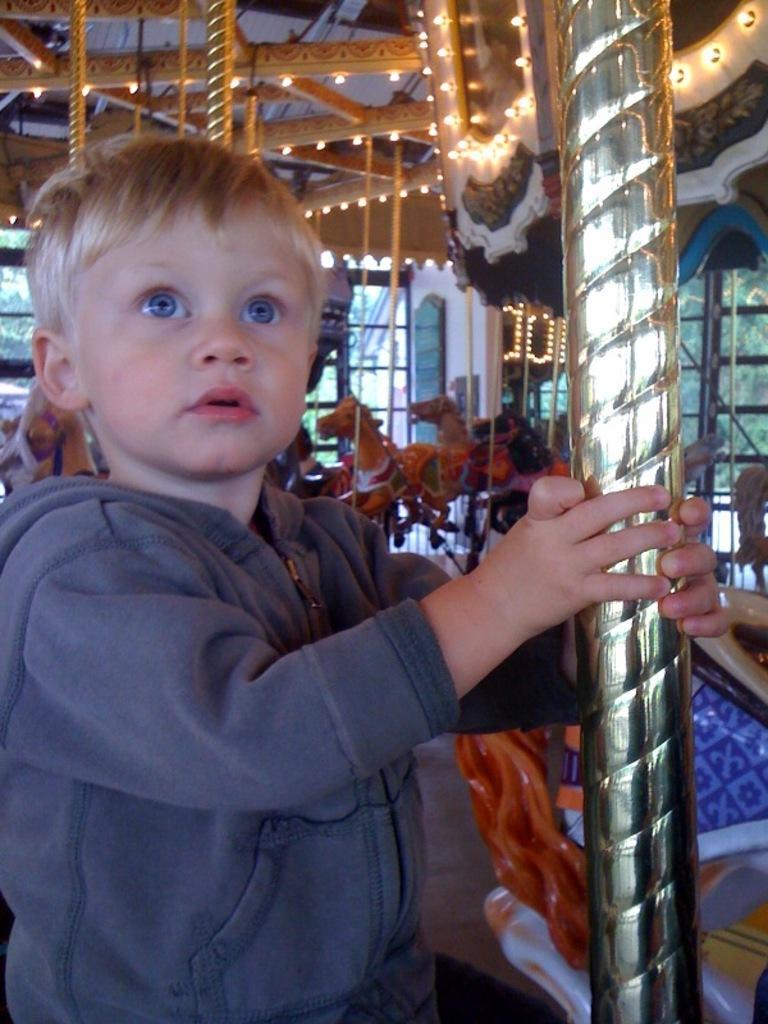Describe this image in one or two sentences. In this image, on the left side, we can see a boy standing and holding a rod in his hand. In the background, we can see some toys, glass window, glass door. At the top, we can see a roof with few lights. 